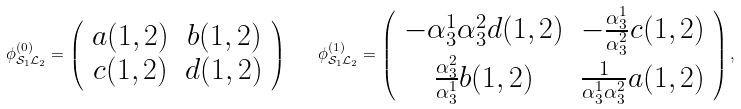<formula> <loc_0><loc_0><loc_500><loc_500>\phi ^ { ( 0 ) } _ { \mathcal { S } _ { 1 } \mathcal { L } _ { 2 } } = \left ( \begin{array} { c c } a ( 1 , 2 ) & b ( 1 , 2 ) \\ c ( 1 , 2 ) & d ( 1 , 2 ) \end{array} \right ) \quad \phi ^ { ( 1 ) } _ { \mathcal { S } _ { 1 } \mathcal { L } _ { 2 } } = \left ( \begin{array} { c c } - \alpha _ { 3 } ^ { 1 } \alpha _ { 3 } ^ { 2 } d ( 1 , 2 ) & - \frac { \alpha _ { 3 } ^ { 1 } } { \alpha _ { 3 } ^ { 2 } } c ( 1 , 2 ) \\ \frac { \alpha _ { 3 } ^ { 2 } } { \alpha _ { 3 } ^ { 1 } } b ( 1 , 2 ) & \frac { 1 } { \alpha _ { 3 } ^ { 1 } \alpha _ { 3 } ^ { 2 } } a ( 1 , 2 ) \end{array} \right ) ,</formula> 